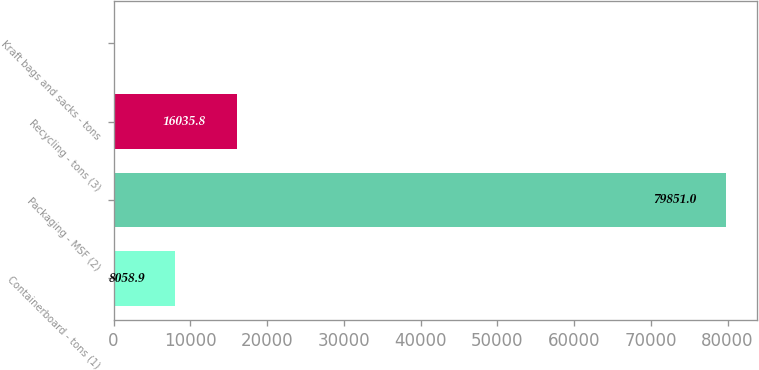Convert chart to OTSL. <chart><loc_0><loc_0><loc_500><loc_500><bar_chart><fcel>Containerboard - tons (1)<fcel>Packaging - MSF (2)<fcel>Recycling - tons (3)<fcel>Kraft bags and sacks - tons<nl><fcel>8058.9<fcel>79851<fcel>16035.8<fcel>82<nl></chart> 